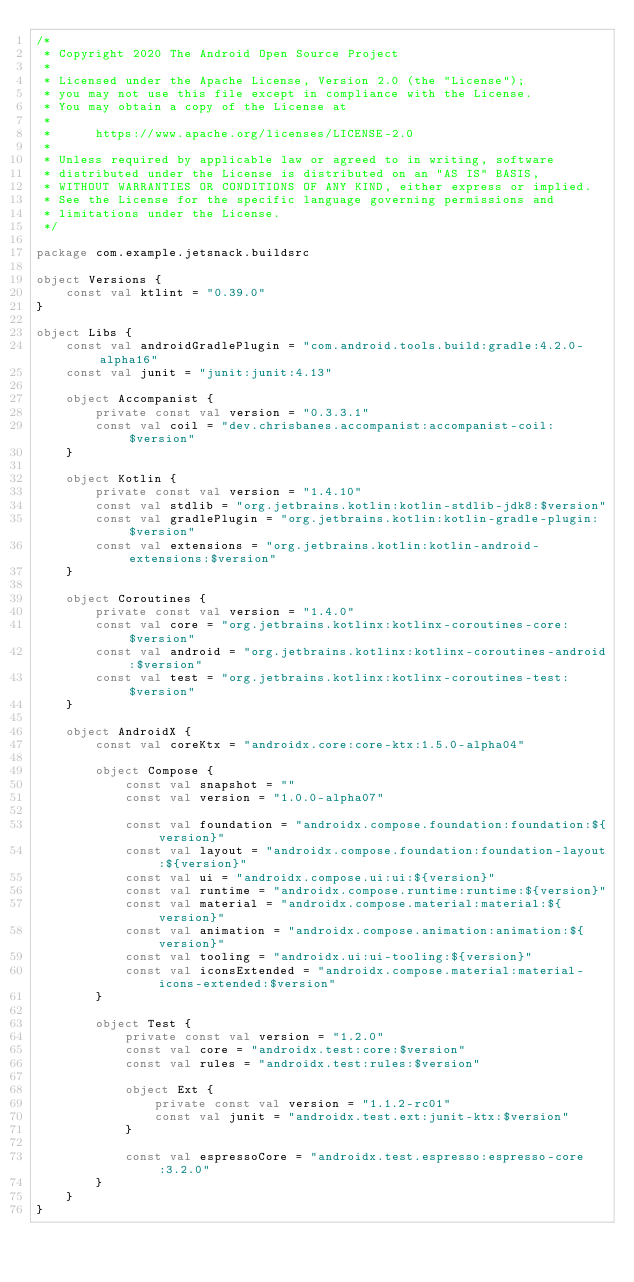<code> <loc_0><loc_0><loc_500><loc_500><_Kotlin_>/*
 * Copyright 2020 The Android Open Source Project
 *
 * Licensed under the Apache License, Version 2.0 (the "License");
 * you may not use this file except in compliance with the License.
 * You may obtain a copy of the License at
 *
 *      https://www.apache.org/licenses/LICENSE-2.0
 *
 * Unless required by applicable law or agreed to in writing, software
 * distributed under the License is distributed on an "AS IS" BASIS,
 * WITHOUT WARRANTIES OR CONDITIONS OF ANY KIND, either express or implied.
 * See the License for the specific language governing permissions and
 * limitations under the License.
 */

package com.example.jetsnack.buildsrc

object Versions {
    const val ktlint = "0.39.0"
}

object Libs {
    const val androidGradlePlugin = "com.android.tools.build:gradle:4.2.0-alpha16"
    const val junit = "junit:junit:4.13"

    object Accompanist {
        private const val version = "0.3.3.1"
        const val coil = "dev.chrisbanes.accompanist:accompanist-coil:$version"
    }

    object Kotlin {
        private const val version = "1.4.10"
        const val stdlib = "org.jetbrains.kotlin:kotlin-stdlib-jdk8:$version"
        const val gradlePlugin = "org.jetbrains.kotlin:kotlin-gradle-plugin:$version"
        const val extensions = "org.jetbrains.kotlin:kotlin-android-extensions:$version"
    }

    object Coroutines {
        private const val version = "1.4.0"
        const val core = "org.jetbrains.kotlinx:kotlinx-coroutines-core:$version"
        const val android = "org.jetbrains.kotlinx:kotlinx-coroutines-android:$version"
        const val test = "org.jetbrains.kotlinx:kotlinx-coroutines-test:$version"
    }

    object AndroidX {
        const val coreKtx = "androidx.core:core-ktx:1.5.0-alpha04"

        object Compose {
            const val snapshot = ""
            const val version = "1.0.0-alpha07"

            const val foundation = "androidx.compose.foundation:foundation:${version}"
            const val layout = "androidx.compose.foundation:foundation-layout:${version}"
            const val ui = "androidx.compose.ui:ui:${version}"
            const val runtime = "androidx.compose.runtime:runtime:${version}"
            const val material = "androidx.compose.material:material:${version}"
            const val animation = "androidx.compose.animation:animation:${version}"
            const val tooling = "androidx.ui:ui-tooling:${version}"
            const val iconsExtended = "androidx.compose.material:material-icons-extended:$version"
        }

        object Test {
            private const val version = "1.2.0"
            const val core = "androidx.test:core:$version"
            const val rules = "androidx.test:rules:$version"

            object Ext {
                private const val version = "1.1.2-rc01"
                const val junit = "androidx.test.ext:junit-ktx:$version"
            }

            const val espressoCore = "androidx.test.espresso:espresso-core:3.2.0"
        }
    }
}
</code> 